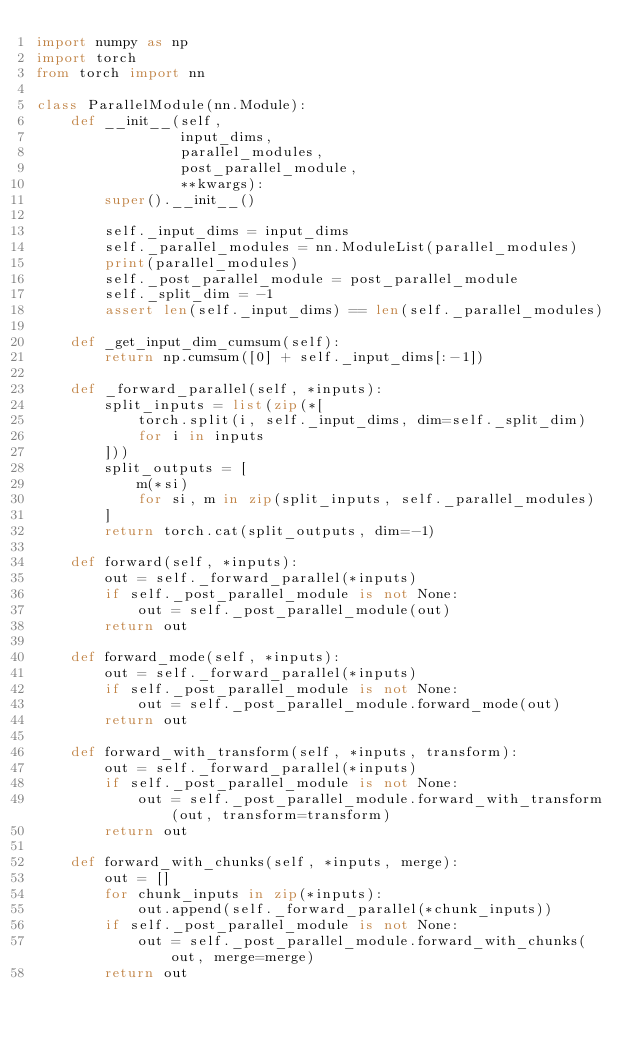Convert code to text. <code><loc_0><loc_0><loc_500><loc_500><_Python_>import numpy as np
import torch
from torch import nn

class ParallelModule(nn.Module):
    def __init__(self,
                 input_dims,
                 parallel_modules,
                 post_parallel_module,
                 **kwargs):
        super().__init__()

        self._input_dims = input_dims
        self._parallel_modules = nn.ModuleList(parallel_modules)
        print(parallel_modules)
        self._post_parallel_module = post_parallel_module
        self._split_dim = -1
        assert len(self._input_dims) == len(self._parallel_modules)

    def _get_input_dim_cumsum(self):
        return np.cumsum([0] + self._input_dims[:-1])

    def _forward_parallel(self, *inputs):
        split_inputs = list(zip(*[
            torch.split(i, self._input_dims, dim=self._split_dim)
            for i in inputs
        ]))
        split_outputs = [
            m(*si)
            for si, m in zip(split_inputs, self._parallel_modules)
        ]
        return torch.cat(split_outputs, dim=-1)

    def forward(self, *inputs):
        out = self._forward_parallel(*inputs)
        if self._post_parallel_module is not None:
            out = self._post_parallel_module(out)
        return out

    def forward_mode(self, *inputs):
        out = self._forward_parallel(*inputs)
        if self._post_parallel_module is not None:
            out = self._post_parallel_module.forward_mode(out)
        return out

    def forward_with_transform(self, *inputs, transform):
        out = self._forward_parallel(*inputs)
        if self._post_parallel_module is not None:
            out = self._post_parallel_module.forward_with_transform(out, transform=transform)
        return out

    def forward_with_chunks(self, *inputs, merge):
        out = []
        for chunk_inputs in zip(*inputs):
            out.append(self._forward_parallel(*chunk_inputs))
        if self._post_parallel_module is not None:
            out = self._post_parallel_module.forward_with_chunks(out, merge=merge)
        return out

</code> 